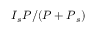<formula> <loc_0><loc_0><loc_500><loc_500>I { _ { s } } P / ( P + P { _ { s } } )</formula> 